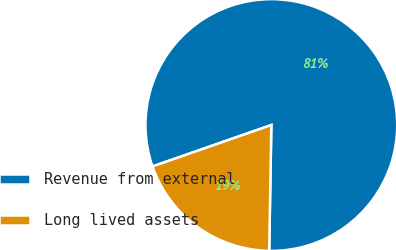<chart> <loc_0><loc_0><loc_500><loc_500><pie_chart><fcel>Revenue from external<fcel>Long lived assets<nl><fcel>80.61%<fcel>19.39%<nl></chart> 